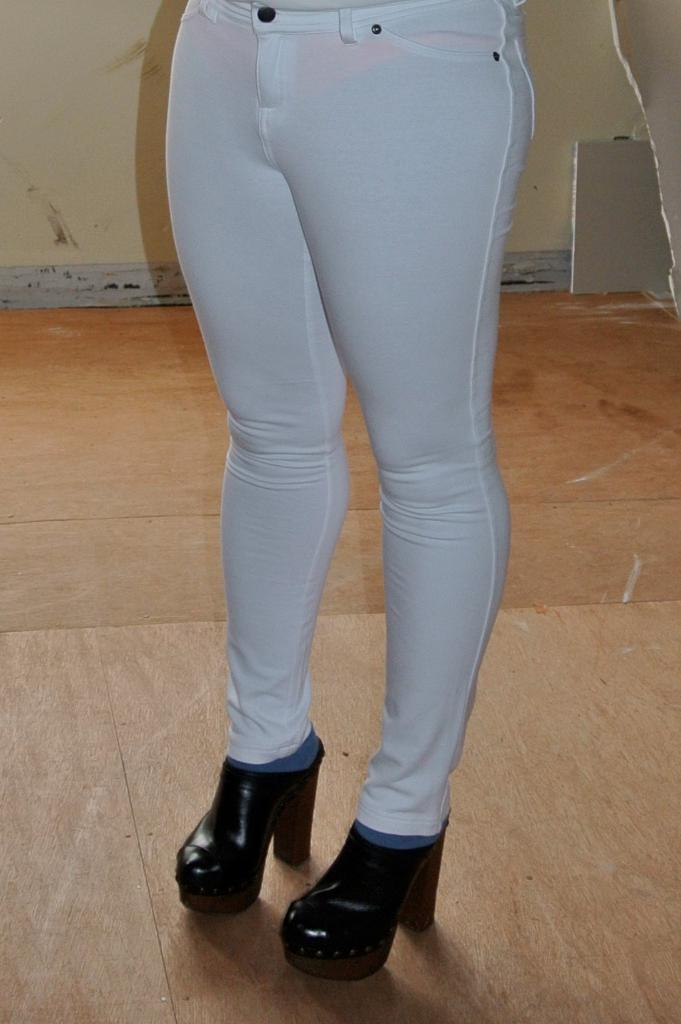Who or what is present in the image? There is a person in the image. What part of the person's body can be seen in the image? The person's legs are visible in the image. What type of footwear is the person wearing? The person is wearing heels. What is the background of the image composed of? There is a wall at the top of the image and a floor visible in the background. What type of hook can be seen hanging from the wall in the image? There is no hook visible in the image; only the person's legs and the wall are present. 